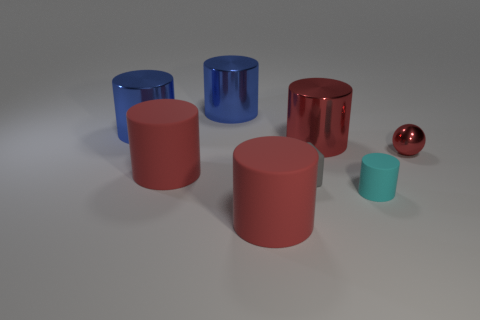What color is the small object that is behind the gray thing?
Provide a succinct answer. Red. What number of blocks are either tiny cyan objects or large things?
Make the answer very short. 0. There is a red cylinder to the left of the big rubber cylinder in front of the cyan matte cylinder; what size is it?
Your response must be concise. Large. Do the small shiny sphere and the large rubber cylinder that is behind the block have the same color?
Offer a very short reply. Yes. How many blue shiny objects are in front of the red sphere?
Make the answer very short. 0. Are there fewer large cylinders than big blue things?
Offer a terse response. No. What size is the cylinder that is on the right side of the gray block and behind the tiny gray rubber block?
Your answer should be compact. Large. Do the object that is in front of the tiny cyan cylinder and the sphere have the same color?
Provide a short and direct response. Yes. Are there fewer gray rubber things that are right of the tiny ball than tiny red rubber cylinders?
Keep it short and to the point. No. There is a big red thing that is the same material as the red ball; what is its shape?
Provide a succinct answer. Cylinder. 